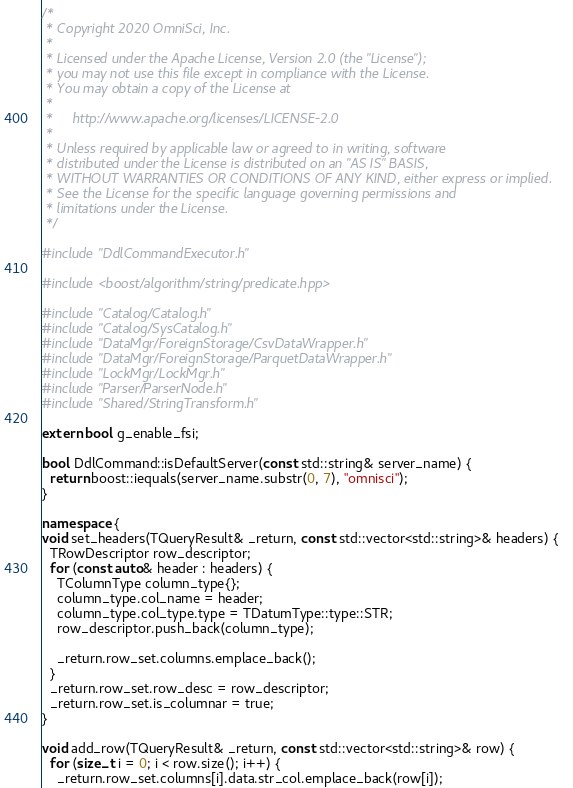<code> <loc_0><loc_0><loc_500><loc_500><_C++_>/*
 * Copyright 2020 OmniSci, Inc.
 *
 * Licensed under the Apache License, Version 2.0 (the "License");
 * you may not use this file except in compliance with the License.
 * You may obtain a copy of the License at
 *
 *     http://www.apache.org/licenses/LICENSE-2.0
 *
 * Unless required by applicable law or agreed to in writing, software
 * distributed under the License is distributed on an "AS IS" BASIS,
 * WITHOUT WARRANTIES OR CONDITIONS OF ANY KIND, either express or implied.
 * See the License for the specific language governing permissions and
 * limitations under the License.
 */

#include "DdlCommandExecutor.h"

#include <boost/algorithm/string/predicate.hpp>

#include "Catalog/Catalog.h"
#include "Catalog/SysCatalog.h"
#include "DataMgr/ForeignStorage/CsvDataWrapper.h"
#include "DataMgr/ForeignStorage/ParquetDataWrapper.h"
#include "LockMgr/LockMgr.h"
#include "Parser/ParserNode.h"
#include "Shared/StringTransform.h"

extern bool g_enable_fsi;

bool DdlCommand::isDefaultServer(const std::string& server_name) {
  return boost::iequals(server_name.substr(0, 7), "omnisci");
}

namespace {
void set_headers(TQueryResult& _return, const std::vector<std::string>& headers) {
  TRowDescriptor row_descriptor;
  for (const auto& header : headers) {
    TColumnType column_type{};
    column_type.col_name = header;
    column_type.col_type.type = TDatumType::type::STR;
    row_descriptor.push_back(column_type);

    _return.row_set.columns.emplace_back();
  }
  _return.row_set.row_desc = row_descriptor;
  _return.row_set.is_columnar = true;
}

void add_row(TQueryResult& _return, const std::vector<std::string>& row) {
  for (size_t i = 0; i < row.size(); i++) {
    _return.row_set.columns[i].data.str_col.emplace_back(row[i]);</code> 